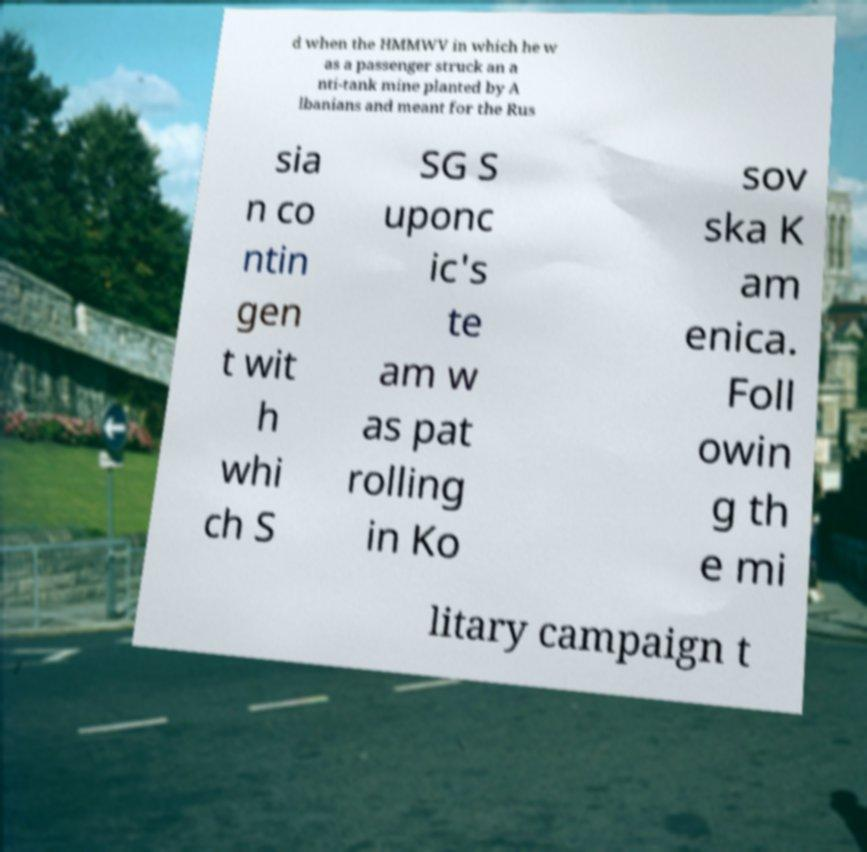I need the written content from this picture converted into text. Can you do that? d when the HMMWV in which he w as a passenger struck an a nti-tank mine planted by A lbanians and meant for the Rus sia n co ntin gen t wit h whi ch S SG S uponc ic's te am w as pat rolling in Ko sov ska K am enica. Foll owin g th e mi litary campaign t 